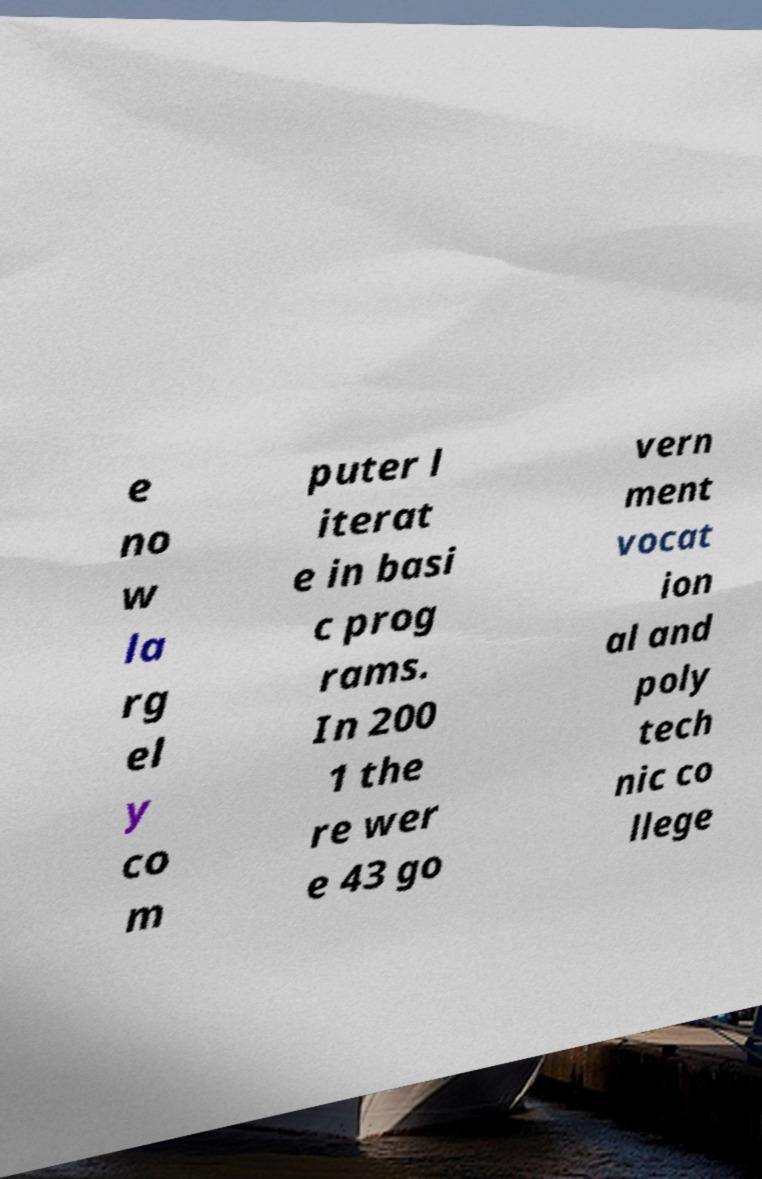Can you read and provide the text displayed in the image?This photo seems to have some interesting text. Can you extract and type it out for me? e no w la rg el y co m puter l iterat e in basi c prog rams. In 200 1 the re wer e 43 go vern ment vocat ion al and poly tech nic co llege 